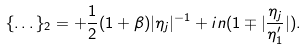Convert formula to latex. <formula><loc_0><loc_0><loc_500><loc_500>\{ \dots \} _ { 2 } = + \frac { 1 } { 2 } ( 1 + \beta ) | \eta _ { j } | ^ { - 1 } + i n ( 1 \mp | \frac { \eta _ { j } } { \eta _ { 1 } ^ { \prime } } | ) .</formula> 